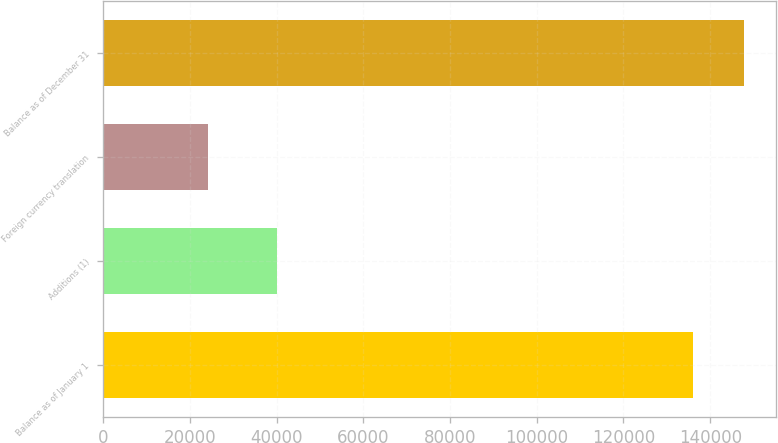Convert chart to OTSL. <chart><loc_0><loc_0><loc_500><loc_500><bar_chart><fcel>Balance as of January 1<fcel>Additions (1)<fcel>Foreign currency translation<fcel>Balance as of December 31<nl><fcel>136006<fcel>40124<fcel>24120<fcel>147718<nl></chart> 